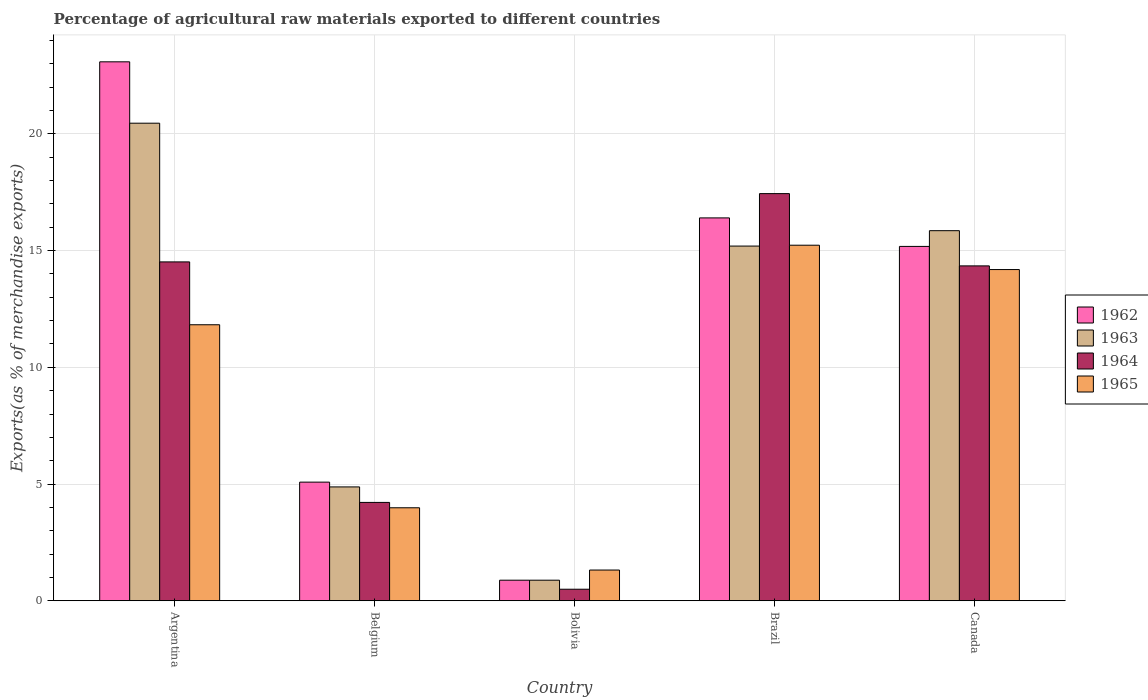How many bars are there on the 4th tick from the left?
Give a very brief answer. 4. What is the label of the 1st group of bars from the left?
Make the answer very short. Argentina. What is the percentage of exports to different countries in 1964 in Argentina?
Your response must be concise. 14.52. Across all countries, what is the maximum percentage of exports to different countries in 1965?
Offer a terse response. 15.23. Across all countries, what is the minimum percentage of exports to different countries in 1962?
Offer a very short reply. 0.88. In which country was the percentage of exports to different countries in 1962 maximum?
Make the answer very short. Argentina. In which country was the percentage of exports to different countries in 1963 minimum?
Ensure brevity in your answer.  Bolivia. What is the total percentage of exports to different countries in 1962 in the graph?
Ensure brevity in your answer.  60.63. What is the difference between the percentage of exports to different countries in 1964 in Bolivia and that in Canada?
Your answer should be very brief. -13.85. What is the difference between the percentage of exports to different countries in 1965 in Canada and the percentage of exports to different countries in 1964 in Argentina?
Your response must be concise. -0.33. What is the average percentage of exports to different countries in 1964 per country?
Offer a very short reply. 10.2. What is the difference between the percentage of exports to different countries of/in 1964 and percentage of exports to different countries of/in 1963 in Argentina?
Provide a short and direct response. -5.94. What is the ratio of the percentage of exports to different countries in 1962 in Belgium to that in Brazil?
Your answer should be compact. 0.31. Is the percentage of exports to different countries in 1962 in Argentina less than that in Bolivia?
Keep it short and to the point. No. Is the difference between the percentage of exports to different countries in 1964 in Bolivia and Canada greater than the difference between the percentage of exports to different countries in 1963 in Bolivia and Canada?
Ensure brevity in your answer.  Yes. What is the difference between the highest and the second highest percentage of exports to different countries in 1962?
Your answer should be very brief. 1.22. What is the difference between the highest and the lowest percentage of exports to different countries in 1965?
Your answer should be very brief. 13.92. In how many countries, is the percentage of exports to different countries in 1962 greater than the average percentage of exports to different countries in 1962 taken over all countries?
Ensure brevity in your answer.  3. What does the 3rd bar from the left in Argentina represents?
Your answer should be very brief. 1964. How many bars are there?
Provide a short and direct response. 20. What is the difference between two consecutive major ticks on the Y-axis?
Keep it short and to the point. 5. Are the values on the major ticks of Y-axis written in scientific E-notation?
Your answer should be compact. No. Does the graph contain any zero values?
Your response must be concise. No. Does the graph contain grids?
Your response must be concise. Yes. Where does the legend appear in the graph?
Offer a very short reply. Center right. How are the legend labels stacked?
Your answer should be compact. Vertical. What is the title of the graph?
Offer a very short reply. Percentage of agricultural raw materials exported to different countries. Does "1964" appear as one of the legend labels in the graph?
Give a very brief answer. Yes. What is the label or title of the Y-axis?
Your answer should be compact. Exports(as % of merchandise exports). What is the Exports(as % of merchandise exports) of 1962 in Argentina?
Your answer should be compact. 23.09. What is the Exports(as % of merchandise exports) in 1963 in Argentina?
Keep it short and to the point. 20.46. What is the Exports(as % of merchandise exports) in 1964 in Argentina?
Your answer should be very brief. 14.52. What is the Exports(as % of merchandise exports) in 1965 in Argentina?
Your answer should be very brief. 11.82. What is the Exports(as % of merchandise exports) in 1962 in Belgium?
Give a very brief answer. 5.08. What is the Exports(as % of merchandise exports) of 1963 in Belgium?
Your answer should be very brief. 4.88. What is the Exports(as % of merchandise exports) of 1964 in Belgium?
Offer a terse response. 4.21. What is the Exports(as % of merchandise exports) in 1965 in Belgium?
Give a very brief answer. 3.98. What is the Exports(as % of merchandise exports) in 1962 in Bolivia?
Your answer should be compact. 0.88. What is the Exports(as % of merchandise exports) of 1963 in Bolivia?
Make the answer very short. 0.88. What is the Exports(as % of merchandise exports) in 1964 in Bolivia?
Make the answer very short. 0.49. What is the Exports(as % of merchandise exports) in 1965 in Bolivia?
Your response must be concise. 1.32. What is the Exports(as % of merchandise exports) of 1962 in Brazil?
Give a very brief answer. 16.4. What is the Exports(as % of merchandise exports) in 1963 in Brazil?
Your answer should be compact. 15.2. What is the Exports(as % of merchandise exports) of 1964 in Brazil?
Give a very brief answer. 17.44. What is the Exports(as % of merchandise exports) in 1965 in Brazil?
Your response must be concise. 15.23. What is the Exports(as % of merchandise exports) of 1962 in Canada?
Give a very brief answer. 15.18. What is the Exports(as % of merchandise exports) of 1963 in Canada?
Make the answer very short. 15.85. What is the Exports(as % of merchandise exports) in 1964 in Canada?
Your answer should be compact. 14.35. What is the Exports(as % of merchandise exports) in 1965 in Canada?
Offer a terse response. 14.19. Across all countries, what is the maximum Exports(as % of merchandise exports) of 1962?
Your answer should be very brief. 23.09. Across all countries, what is the maximum Exports(as % of merchandise exports) of 1963?
Ensure brevity in your answer.  20.46. Across all countries, what is the maximum Exports(as % of merchandise exports) in 1964?
Make the answer very short. 17.44. Across all countries, what is the maximum Exports(as % of merchandise exports) of 1965?
Ensure brevity in your answer.  15.23. Across all countries, what is the minimum Exports(as % of merchandise exports) in 1962?
Keep it short and to the point. 0.88. Across all countries, what is the minimum Exports(as % of merchandise exports) in 1963?
Give a very brief answer. 0.88. Across all countries, what is the minimum Exports(as % of merchandise exports) of 1964?
Your response must be concise. 0.49. Across all countries, what is the minimum Exports(as % of merchandise exports) of 1965?
Ensure brevity in your answer.  1.32. What is the total Exports(as % of merchandise exports) of 1962 in the graph?
Ensure brevity in your answer.  60.63. What is the total Exports(as % of merchandise exports) in 1963 in the graph?
Your answer should be compact. 57.27. What is the total Exports(as % of merchandise exports) of 1964 in the graph?
Provide a succinct answer. 51.01. What is the total Exports(as % of merchandise exports) in 1965 in the graph?
Your answer should be very brief. 46.55. What is the difference between the Exports(as % of merchandise exports) of 1962 in Argentina and that in Belgium?
Your answer should be very brief. 18.01. What is the difference between the Exports(as % of merchandise exports) of 1963 in Argentina and that in Belgium?
Provide a short and direct response. 15.58. What is the difference between the Exports(as % of merchandise exports) in 1964 in Argentina and that in Belgium?
Your answer should be compact. 10.3. What is the difference between the Exports(as % of merchandise exports) in 1965 in Argentina and that in Belgium?
Provide a short and direct response. 7.84. What is the difference between the Exports(as % of merchandise exports) of 1962 in Argentina and that in Bolivia?
Offer a terse response. 22.21. What is the difference between the Exports(as % of merchandise exports) of 1963 in Argentina and that in Bolivia?
Give a very brief answer. 19.58. What is the difference between the Exports(as % of merchandise exports) in 1964 in Argentina and that in Bolivia?
Your answer should be compact. 14.02. What is the difference between the Exports(as % of merchandise exports) of 1965 in Argentina and that in Bolivia?
Offer a terse response. 10.51. What is the difference between the Exports(as % of merchandise exports) of 1962 in Argentina and that in Brazil?
Offer a terse response. 6.69. What is the difference between the Exports(as % of merchandise exports) in 1963 in Argentina and that in Brazil?
Provide a succinct answer. 5.26. What is the difference between the Exports(as % of merchandise exports) in 1964 in Argentina and that in Brazil?
Offer a terse response. -2.93. What is the difference between the Exports(as % of merchandise exports) of 1965 in Argentina and that in Brazil?
Give a very brief answer. -3.41. What is the difference between the Exports(as % of merchandise exports) in 1962 in Argentina and that in Canada?
Offer a very short reply. 7.91. What is the difference between the Exports(as % of merchandise exports) of 1963 in Argentina and that in Canada?
Your answer should be very brief. 4.6. What is the difference between the Exports(as % of merchandise exports) in 1964 in Argentina and that in Canada?
Make the answer very short. 0.17. What is the difference between the Exports(as % of merchandise exports) in 1965 in Argentina and that in Canada?
Ensure brevity in your answer.  -2.36. What is the difference between the Exports(as % of merchandise exports) of 1962 in Belgium and that in Bolivia?
Your response must be concise. 4.2. What is the difference between the Exports(as % of merchandise exports) of 1963 in Belgium and that in Bolivia?
Make the answer very short. 4. What is the difference between the Exports(as % of merchandise exports) of 1964 in Belgium and that in Bolivia?
Provide a succinct answer. 3.72. What is the difference between the Exports(as % of merchandise exports) in 1965 in Belgium and that in Bolivia?
Your response must be concise. 2.67. What is the difference between the Exports(as % of merchandise exports) of 1962 in Belgium and that in Brazil?
Offer a very short reply. -11.32. What is the difference between the Exports(as % of merchandise exports) of 1963 in Belgium and that in Brazil?
Provide a short and direct response. -10.32. What is the difference between the Exports(as % of merchandise exports) in 1964 in Belgium and that in Brazil?
Give a very brief answer. -13.23. What is the difference between the Exports(as % of merchandise exports) of 1965 in Belgium and that in Brazil?
Provide a succinct answer. -11.25. What is the difference between the Exports(as % of merchandise exports) in 1962 in Belgium and that in Canada?
Keep it short and to the point. -10.1. What is the difference between the Exports(as % of merchandise exports) of 1963 in Belgium and that in Canada?
Your answer should be compact. -10.98. What is the difference between the Exports(as % of merchandise exports) in 1964 in Belgium and that in Canada?
Keep it short and to the point. -10.13. What is the difference between the Exports(as % of merchandise exports) in 1965 in Belgium and that in Canada?
Keep it short and to the point. -10.21. What is the difference between the Exports(as % of merchandise exports) of 1962 in Bolivia and that in Brazil?
Give a very brief answer. -15.52. What is the difference between the Exports(as % of merchandise exports) in 1963 in Bolivia and that in Brazil?
Ensure brevity in your answer.  -14.31. What is the difference between the Exports(as % of merchandise exports) in 1964 in Bolivia and that in Brazil?
Give a very brief answer. -16.95. What is the difference between the Exports(as % of merchandise exports) in 1965 in Bolivia and that in Brazil?
Offer a terse response. -13.92. What is the difference between the Exports(as % of merchandise exports) in 1962 in Bolivia and that in Canada?
Offer a very short reply. -14.3. What is the difference between the Exports(as % of merchandise exports) in 1963 in Bolivia and that in Canada?
Provide a short and direct response. -14.97. What is the difference between the Exports(as % of merchandise exports) of 1964 in Bolivia and that in Canada?
Offer a very short reply. -13.85. What is the difference between the Exports(as % of merchandise exports) of 1965 in Bolivia and that in Canada?
Your response must be concise. -12.87. What is the difference between the Exports(as % of merchandise exports) of 1962 in Brazil and that in Canada?
Your answer should be very brief. 1.22. What is the difference between the Exports(as % of merchandise exports) of 1963 in Brazil and that in Canada?
Make the answer very short. -0.66. What is the difference between the Exports(as % of merchandise exports) in 1964 in Brazil and that in Canada?
Give a very brief answer. 3.1. What is the difference between the Exports(as % of merchandise exports) of 1965 in Brazil and that in Canada?
Offer a terse response. 1.04. What is the difference between the Exports(as % of merchandise exports) in 1962 in Argentina and the Exports(as % of merchandise exports) in 1963 in Belgium?
Your answer should be compact. 18.21. What is the difference between the Exports(as % of merchandise exports) of 1962 in Argentina and the Exports(as % of merchandise exports) of 1964 in Belgium?
Keep it short and to the point. 18.87. What is the difference between the Exports(as % of merchandise exports) of 1962 in Argentina and the Exports(as % of merchandise exports) of 1965 in Belgium?
Keep it short and to the point. 19.1. What is the difference between the Exports(as % of merchandise exports) in 1963 in Argentina and the Exports(as % of merchandise exports) in 1964 in Belgium?
Ensure brevity in your answer.  16.25. What is the difference between the Exports(as % of merchandise exports) in 1963 in Argentina and the Exports(as % of merchandise exports) in 1965 in Belgium?
Give a very brief answer. 16.48. What is the difference between the Exports(as % of merchandise exports) in 1964 in Argentina and the Exports(as % of merchandise exports) in 1965 in Belgium?
Offer a terse response. 10.53. What is the difference between the Exports(as % of merchandise exports) of 1962 in Argentina and the Exports(as % of merchandise exports) of 1963 in Bolivia?
Provide a short and direct response. 22.21. What is the difference between the Exports(as % of merchandise exports) of 1962 in Argentina and the Exports(as % of merchandise exports) of 1964 in Bolivia?
Ensure brevity in your answer.  22.59. What is the difference between the Exports(as % of merchandise exports) of 1962 in Argentina and the Exports(as % of merchandise exports) of 1965 in Bolivia?
Offer a terse response. 21.77. What is the difference between the Exports(as % of merchandise exports) in 1963 in Argentina and the Exports(as % of merchandise exports) in 1964 in Bolivia?
Keep it short and to the point. 19.96. What is the difference between the Exports(as % of merchandise exports) of 1963 in Argentina and the Exports(as % of merchandise exports) of 1965 in Bolivia?
Your answer should be compact. 19.14. What is the difference between the Exports(as % of merchandise exports) of 1964 in Argentina and the Exports(as % of merchandise exports) of 1965 in Bolivia?
Ensure brevity in your answer.  13.2. What is the difference between the Exports(as % of merchandise exports) in 1962 in Argentina and the Exports(as % of merchandise exports) in 1963 in Brazil?
Give a very brief answer. 7.89. What is the difference between the Exports(as % of merchandise exports) of 1962 in Argentina and the Exports(as % of merchandise exports) of 1964 in Brazil?
Make the answer very short. 5.65. What is the difference between the Exports(as % of merchandise exports) of 1962 in Argentina and the Exports(as % of merchandise exports) of 1965 in Brazil?
Offer a very short reply. 7.86. What is the difference between the Exports(as % of merchandise exports) of 1963 in Argentina and the Exports(as % of merchandise exports) of 1964 in Brazil?
Provide a succinct answer. 3.02. What is the difference between the Exports(as % of merchandise exports) of 1963 in Argentina and the Exports(as % of merchandise exports) of 1965 in Brazil?
Ensure brevity in your answer.  5.23. What is the difference between the Exports(as % of merchandise exports) in 1964 in Argentina and the Exports(as % of merchandise exports) in 1965 in Brazil?
Offer a terse response. -0.72. What is the difference between the Exports(as % of merchandise exports) in 1962 in Argentina and the Exports(as % of merchandise exports) in 1963 in Canada?
Your answer should be compact. 7.23. What is the difference between the Exports(as % of merchandise exports) in 1962 in Argentina and the Exports(as % of merchandise exports) in 1964 in Canada?
Your response must be concise. 8.74. What is the difference between the Exports(as % of merchandise exports) in 1962 in Argentina and the Exports(as % of merchandise exports) in 1965 in Canada?
Make the answer very short. 8.9. What is the difference between the Exports(as % of merchandise exports) in 1963 in Argentina and the Exports(as % of merchandise exports) in 1964 in Canada?
Keep it short and to the point. 6.11. What is the difference between the Exports(as % of merchandise exports) in 1963 in Argentina and the Exports(as % of merchandise exports) in 1965 in Canada?
Offer a terse response. 6.27. What is the difference between the Exports(as % of merchandise exports) of 1964 in Argentina and the Exports(as % of merchandise exports) of 1965 in Canada?
Give a very brief answer. 0.33. What is the difference between the Exports(as % of merchandise exports) of 1962 in Belgium and the Exports(as % of merchandise exports) of 1963 in Bolivia?
Provide a short and direct response. 4.2. What is the difference between the Exports(as % of merchandise exports) of 1962 in Belgium and the Exports(as % of merchandise exports) of 1964 in Bolivia?
Give a very brief answer. 4.59. What is the difference between the Exports(as % of merchandise exports) of 1962 in Belgium and the Exports(as % of merchandise exports) of 1965 in Bolivia?
Make the answer very short. 3.77. What is the difference between the Exports(as % of merchandise exports) in 1963 in Belgium and the Exports(as % of merchandise exports) in 1964 in Bolivia?
Provide a succinct answer. 4.38. What is the difference between the Exports(as % of merchandise exports) of 1963 in Belgium and the Exports(as % of merchandise exports) of 1965 in Bolivia?
Offer a very short reply. 3.56. What is the difference between the Exports(as % of merchandise exports) of 1964 in Belgium and the Exports(as % of merchandise exports) of 1965 in Bolivia?
Offer a very short reply. 2.9. What is the difference between the Exports(as % of merchandise exports) of 1962 in Belgium and the Exports(as % of merchandise exports) of 1963 in Brazil?
Offer a very short reply. -10.11. What is the difference between the Exports(as % of merchandise exports) in 1962 in Belgium and the Exports(as % of merchandise exports) in 1964 in Brazil?
Provide a short and direct response. -12.36. What is the difference between the Exports(as % of merchandise exports) of 1962 in Belgium and the Exports(as % of merchandise exports) of 1965 in Brazil?
Your response must be concise. -10.15. What is the difference between the Exports(as % of merchandise exports) of 1963 in Belgium and the Exports(as % of merchandise exports) of 1964 in Brazil?
Give a very brief answer. -12.56. What is the difference between the Exports(as % of merchandise exports) of 1963 in Belgium and the Exports(as % of merchandise exports) of 1965 in Brazil?
Your answer should be very brief. -10.35. What is the difference between the Exports(as % of merchandise exports) of 1964 in Belgium and the Exports(as % of merchandise exports) of 1965 in Brazil?
Give a very brief answer. -11.02. What is the difference between the Exports(as % of merchandise exports) in 1962 in Belgium and the Exports(as % of merchandise exports) in 1963 in Canada?
Give a very brief answer. -10.77. What is the difference between the Exports(as % of merchandise exports) of 1962 in Belgium and the Exports(as % of merchandise exports) of 1964 in Canada?
Offer a very short reply. -9.26. What is the difference between the Exports(as % of merchandise exports) in 1962 in Belgium and the Exports(as % of merchandise exports) in 1965 in Canada?
Your answer should be very brief. -9.11. What is the difference between the Exports(as % of merchandise exports) of 1963 in Belgium and the Exports(as % of merchandise exports) of 1964 in Canada?
Provide a short and direct response. -9.47. What is the difference between the Exports(as % of merchandise exports) of 1963 in Belgium and the Exports(as % of merchandise exports) of 1965 in Canada?
Provide a succinct answer. -9.31. What is the difference between the Exports(as % of merchandise exports) of 1964 in Belgium and the Exports(as % of merchandise exports) of 1965 in Canada?
Offer a very short reply. -9.98. What is the difference between the Exports(as % of merchandise exports) in 1962 in Bolivia and the Exports(as % of merchandise exports) in 1963 in Brazil?
Your answer should be very brief. -14.31. What is the difference between the Exports(as % of merchandise exports) in 1962 in Bolivia and the Exports(as % of merchandise exports) in 1964 in Brazil?
Ensure brevity in your answer.  -16.56. What is the difference between the Exports(as % of merchandise exports) in 1962 in Bolivia and the Exports(as % of merchandise exports) in 1965 in Brazil?
Make the answer very short. -14.35. What is the difference between the Exports(as % of merchandise exports) of 1963 in Bolivia and the Exports(as % of merchandise exports) of 1964 in Brazil?
Offer a terse response. -16.56. What is the difference between the Exports(as % of merchandise exports) in 1963 in Bolivia and the Exports(as % of merchandise exports) in 1965 in Brazil?
Offer a terse response. -14.35. What is the difference between the Exports(as % of merchandise exports) in 1964 in Bolivia and the Exports(as % of merchandise exports) in 1965 in Brazil?
Provide a succinct answer. -14.74. What is the difference between the Exports(as % of merchandise exports) of 1962 in Bolivia and the Exports(as % of merchandise exports) of 1963 in Canada?
Ensure brevity in your answer.  -14.97. What is the difference between the Exports(as % of merchandise exports) of 1962 in Bolivia and the Exports(as % of merchandise exports) of 1964 in Canada?
Make the answer very short. -13.46. What is the difference between the Exports(as % of merchandise exports) of 1962 in Bolivia and the Exports(as % of merchandise exports) of 1965 in Canada?
Provide a succinct answer. -13.31. What is the difference between the Exports(as % of merchandise exports) in 1963 in Bolivia and the Exports(as % of merchandise exports) in 1964 in Canada?
Offer a very short reply. -13.46. What is the difference between the Exports(as % of merchandise exports) in 1963 in Bolivia and the Exports(as % of merchandise exports) in 1965 in Canada?
Your response must be concise. -13.31. What is the difference between the Exports(as % of merchandise exports) in 1964 in Bolivia and the Exports(as % of merchandise exports) in 1965 in Canada?
Offer a terse response. -13.7. What is the difference between the Exports(as % of merchandise exports) of 1962 in Brazil and the Exports(as % of merchandise exports) of 1963 in Canada?
Give a very brief answer. 0.55. What is the difference between the Exports(as % of merchandise exports) in 1962 in Brazil and the Exports(as % of merchandise exports) in 1964 in Canada?
Provide a succinct answer. 2.06. What is the difference between the Exports(as % of merchandise exports) in 1962 in Brazil and the Exports(as % of merchandise exports) in 1965 in Canada?
Your answer should be very brief. 2.21. What is the difference between the Exports(as % of merchandise exports) of 1963 in Brazil and the Exports(as % of merchandise exports) of 1964 in Canada?
Ensure brevity in your answer.  0.85. What is the difference between the Exports(as % of merchandise exports) in 1963 in Brazil and the Exports(as % of merchandise exports) in 1965 in Canada?
Your answer should be very brief. 1.01. What is the difference between the Exports(as % of merchandise exports) in 1964 in Brazil and the Exports(as % of merchandise exports) in 1965 in Canada?
Your answer should be compact. 3.25. What is the average Exports(as % of merchandise exports) of 1962 per country?
Your answer should be very brief. 12.13. What is the average Exports(as % of merchandise exports) of 1963 per country?
Provide a short and direct response. 11.45. What is the average Exports(as % of merchandise exports) of 1964 per country?
Offer a terse response. 10.2. What is the average Exports(as % of merchandise exports) in 1965 per country?
Ensure brevity in your answer.  9.31. What is the difference between the Exports(as % of merchandise exports) in 1962 and Exports(as % of merchandise exports) in 1963 in Argentina?
Offer a very short reply. 2.63. What is the difference between the Exports(as % of merchandise exports) of 1962 and Exports(as % of merchandise exports) of 1964 in Argentina?
Offer a terse response. 8.57. What is the difference between the Exports(as % of merchandise exports) in 1962 and Exports(as % of merchandise exports) in 1965 in Argentina?
Provide a short and direct response. 11.26. What is the difference between the Exports(as % of merchandise exports) in 1963 and Exports(as % of merchandise exports) in 1964 in Argentina?
Ensure brevity in your answer.  5.94. What is the difference between the Exports(as % of merchandise exports) in 1963 and Exports(as % of merchandise exports) in 1965 in Argentina?
Make the answer very short. 8.63. What is the difference between the Exports(as % of merchandise exports) of 1964 and Exports(as % of merchandise exports) of 1965 in Argentina?
Make the answer very short. 2.69. What is the difference between the Exports(as % of merchandise exports) in 1962 and Exports(as % of merchandise exports) in 1963 in Belgium?
Offer a very short reply. 0.2. What is the difference between the Exports(as % of merchandise exports) of 1962 and Exports(as % of merchandise exports) of 1964 in Belgium?
Offer a terse response. 0.87. What is the difference between the Exports(as % of merchandise exports) of 1962 and Exports(as % of merchandise exports) of 1965 in Belgium?
Offer a very short reply. 1.1. What is the difference between the Exports(as % of merchandise exports) in 1963 and Exports(as % of merchandise exports) in 1964 in Belgium?
Your response must be concise. 0.66. What is the difference between the Exports(as % of merchandise exports) in 1963 and Exports(as % of merchandise exports) in 1965 in Belgium?
Keep it short and to the point. 0.89. What is the difference between the Exports(as % of merchandise exports) in 1964 and Exports(as % of merchandise exports) in 1965 in Belgium?
Ensure brevity in your answer.  0.23. What is the difference between the Exports(as % of merchandise exports) in 1962 and Exports(as % of merchandise exports) in 1964 in Bolivia?
Your response must be concise. 0.39. What is the difference between the Exports(as % of merchandise exports) in 1962 and Exports(as % of merchandise exports) in 1965 in Bolivia?
Offer a very short reply. -0.43. What is the difference between the Exports(as % of merchandise exports) of 1963 and Exports(as % of merchandise exports) of 1964 in Bolivia?
Your response must be concise. 0.39. What is the difference between the Exports(as % of merchandise exports) in 1963 and Exports(as % of merchandise exports) in 1965 in Bolivia?
Keep it short and to the point. -0.43. What is the difference between the Exports(as % of merchandise exports) of 1964 and Exports(as % of merchandise exports) of 1965 in Bolivia?
Offer a terse response. -0.82. What is the difference between the Exports(as % of merchandise exports) of 1962 and Exports(as % of merchandise exports) of 1963 in Brazil?
Your answer should be compact. 1.21. What is the difference between the Exports(as % of merchandise exports) of 1962 and Exports(as % of merchandise exports) of 1964 in Brazil?
Ensure brevity in your answer.  -1.04. What is the difference between the Exports(as % of merchandise exports) in 1962 and Exports(as % of merchandise exports) in 1965 in Brazil?
Make the answer very short. 1.17. What is the difference between the Exports(as % of merchandise exports) of 1963 and Exports(as % of merchandise exports) of 1964 in Brazil?
Provide a short and direct response. -2.25. What is the difference between the Exports(as % of merchandise exports) of 1963 and Exports(as % of merchandise exports) of 1965 in Brazil?
Your answer should be very brief. -0.04. What is the difference between the Exports(as % of merchandise exports) of 1964 and Exports(as % of merchandise exports) of 1965 in Brazil?
Provide a succinct answer. 2.21. What is the difference between the Exports(as % of merchandise exports) in 1962 and Exports(as % of merchandise exports) in 1963 in Canada?
Your answer should be compact. -0.67. What is the difference between the Exports(as % of merchandise exports) of 1962 and Exports(as % of merchandise exports) of 1964 in Canada?
Your answer should be very brief. 0.83. What is the difference between the Exports(as % of merchandise exports) of 1963 and Exports(as % of merchandise exports) of 1964 in Canada?
Offer a terse response. 1.51. What is the difference between the Exports(as % of merchandise exports) of 1963 and Exports(as % of merchandise exports) of 1965 in Canada?
Make the answer very short. 1.67. What is the difference between the Exports(as % of merchandise exports) in 1964 and Exports(as % of merchandise exports) in 1965 in Canada?
Make the answer very short. 0.16. What is the ratio of the Exports(as % of merchandise exports) of 1962 in Argentina to that in Belgium?
Ensure brevity in your answer.  4.54. What is the ratio of the Exports(as % of merchandise exports) in 1963 in Argentina to that in Belgium?
Your answer should be very brief. 4.19. What is the ratio of the Exports(as % of merchandise exports) of 1964 in Argentina to that in Belgium?
Your answer should be very brief. 3.45. What is the ratio of the Exports(as % of merchandise exports) in 1965 in Argentina to that in Belgium?
Keep it short and to the point. 2.97. What is the ratio of the Exports(as % of merchandise exports) in 1962 in Argentina to that in Bolivia?
Offer a very short reply. 26.19. What is the ratio of the Exports(as % of merchandise exports) in 1963 in Argentina to that in Bolivia?
Your answer should be very brief. 23.21. What is the ratio of the Exports(as % of merchandise exports) in 1964 in Argentina to that in Bolivia?
Keep it short and to the point. 29.36. What is the ratio of the Exports(as % of merchandise exports) in 1965 in Argentina to that in Bolivia?
Your response must be concise. 8.98. What is the ratio of the Exports(as % of merchandise exports) in 1962 in Argentina to that in Brazil?
Your answer should be compact. 1.41. What is the ratio of the Exports(as % of merchandise exports) of 1963 in Argentina to that in Brazil?
Your answer should be compact. 1.35. What is the ratio of the Exports(as % of merchandise exports) in 1964 in Argentina to that in Brazil?
Your answer should be very brief. 0.83. What is the ratio of the Exports(as % of merchandise exports) of 1965 in Argentina to that in Brazil?
Keep it short and to the point. 0.78. What is the ratio of the Exports(as % of merchandise exports) of 1962 in Argentina to that in Canada?
Provide a succinct answer. 1.52. What is the ratio of the Exports(as % of merchandise exports) in 1963 in Argentina to that in Canada?
Your response must be concise. 1.29. What is the ratio of the Exports(as % of merchandise exports) of 1964 in Argentina to that in Canada?
Ensure brevity in your answer.  1.01. What is the ratio of the Exports(as % of merchandise exports) in 1965 in Argentina to that in Canada?
Ensure brevity in your answer.  0.83. What is the ratio of the Exports(as % of merchandise exports) of 1962 in Belgium to that in Bolivia?
Offer a terse response. 5.77. What is the ratio of the Exports(as % of merchandise exports) in 1963 in Belgium to that in Bolivia?
Offer a terse response. 5.53. What is the ratio of the Exports(as % of merchandise exports) in 1964 in Belgium to that in Bolivia?
Your answer should be very brief. 8.52. What is the ratio of the Exports(as % of merchandise exports) of 1965 in Belgium to that in Bolivia?
Give a very brief answer. 3.03. What is the ratio of the Exports(as % of merchandise exports) of 1962 in Belgium to that in Brazil?
Ensure brevity in your answer.  0.31. What is the ratio of the Exports(as % of merchandise exports) of 1963 in Belgium to that in Brazil?
Offer a terse response. 0.32. What is the ratio of the Exports(as % of merchandise exports) of 1964 in Belgium to that in Brazil?
Provide a short and direct response. 0.24. What is the ratio of the Exports(as % of merchandise exports) in 1965 in Belgium to that in Brazil?
Your answer should be compact. 0.26. What is the ratio of the Exports(as % of merchandise exports) in 1962 in Belgium to that in Canada?
Make the answer very short. 0.33. What is the ratio of the Exports(as % of merchandise exports) in 1963 in Belgium to that in Canada?
Provide a succinct answer. 0.31. What is the ratio of the Exports(as % of merchandise exports) of 1964 in Belgium to that in Canada?
Ensure brevity in your answer.  0.29. What is the ratio of the Exports(as % of merchandise exports) of 1965 in Belgium to that in Canada?
Ensure brevity in your answer.  0.28. What is the ratio of the Exports(as % of merchandise exports) of 1962 in Bolivia to that in Brazil?
Your answer should be very brief. 0.05. What is the ratio of the Exports(as % of merchandise exports) of 1963 in Bolivia to that in Brazil?
Provide a succinct answer. 0.06. What is the ratio of the Exports(as % of merchandise exports) of 1964 in Bolivia to that in Brazil?
Offer a terse response. 0.03. What is the ratio of the Exports(as % of merchandise exports) in 1965 in Bolivia to that in Brazil?
Give a very brief answer. 0.09. What is the ratio of the Exports(as % of merchandise exports) in 1962 in Bolivia to that in Canada?
Offer a terse response. 0.06. What is the ratio of the Exports(as % of merchandise exports) in 1963 in Bolivia to that in Canada?
Your answer should be very brief. 0.06. What is the ratio of the Exports(as % of merchandise exports) in 1964 in Bolivia to that in Canada?
Your response must be concise. 0.03. What is the ratio of the Exports(as % of merchandise exports) in 1965 in Bolivia to that in Canada?
Provide a succinct answer. 0.09. What is the ratio of the Exports(as % of merchandise exports) of 1962 in Brazil to that in Canada?
Your answer should be very brief. 1.08. What is the ratio of the Exports(as % of merchandise exports) in 1963 in Brazil to that in Canada?
Provide a succinct answer. 0.96. What is the ratio of the Exports(as % of merchandise exports) of 1964 in Brazil to that in Canada?
Provide a succinct answer. 1.22. What is the ratio of the Exports(as % of merchandise exports) of 1965 in Brazil to that in Canada?
Your response must be concise. 1.07. What is the difference between the highest and the second highest Exports(as % of merchandise exports) in 1962?
Offer a very short reply. 6.69. What is the difference between the highest and the second highest Exports(as % of merchandise exports) of 1963?
Ensure brevity in your answer.  4.6. What is the difference between the highest and the second highest Exports(as % of merchandise exports) of 1964?
Offer a terse response. 2.93. What is the difference between the highest and the second highest Exports(as % of merchandise exports) of 1965?
Keep it short and to the point. 1.04. What is the difference between the highest and the lowest Exports(as % of merchandise exports) of 1962?
Ensure brevity in your answer.  22.21. What is the difference between the highest and the lowest Exports(as % of merchandise exports) of 1963?
Give a very brief answer. 19.58. What is the difference between the highest and the lowest Exports(as % of merchandise exports) in 1964?
Your answer should be compact. 16.95. What is the difference between the highest and the lowest Exports(as % of merchandise exports) in 1965?
Provide a short and direct response. 13.92. 